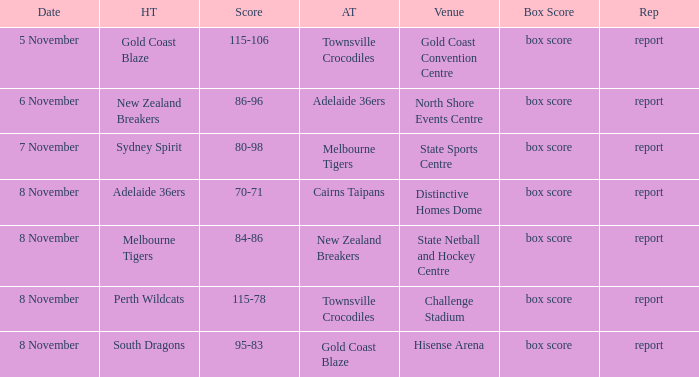What was the box score during a game that had a score of 86-96? Box score. 